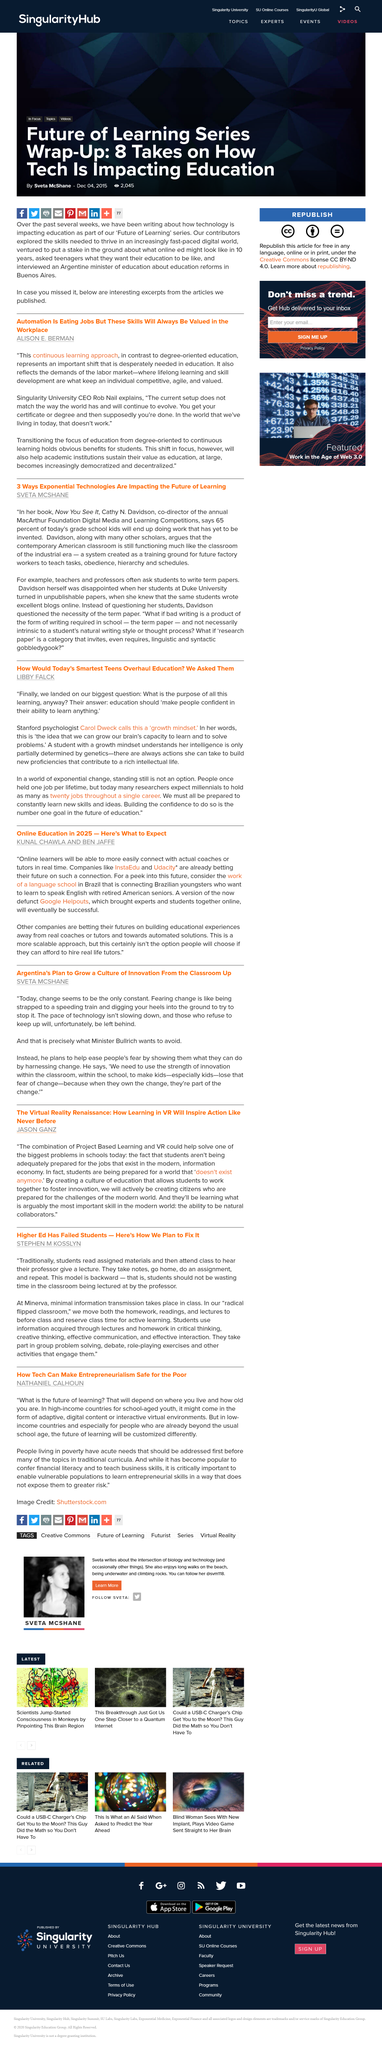Specify some key components in this picture. The author of the book "Now You See It" is Cathy N. Davidson. Singularity University plans to sustain its value as an academic institution by transitioning the focus of education from degree-oriented to continuous learning, ensuring that our programs and resources remain relevant and valuable to our students and stakeholders. Singularity University is headed by Rob Nail, who serves as CEO of the organization. It is predicted that a vast majority of today's grade school children will be engaged in work that has not yet been created, based on the insights of Davidson. Automation is having a significant impact on employment, as it is leading to the loss of jobs. 